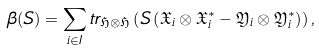<formula> <loc_0><loc_0><loc_500><loc_500>\beta ( S ) = \sum _ { i \in I } t r _ { \mathfrak { H } \otimes \mathfrak { H } } \left ( S \left ( \mathfrak { X } _ { i } \otimes \mathfrak { X } ^ { * } _ { i } - \mathfrak { Y } _ { i } \otimes \mathfrak { Y } ^ { * } _ { i } \right ) \right ) ,</formula> 